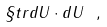<formula> <loc_0><loc_0><loc_500><loc_500>\S t r { d U \cdot d U } \ ,</formula> 